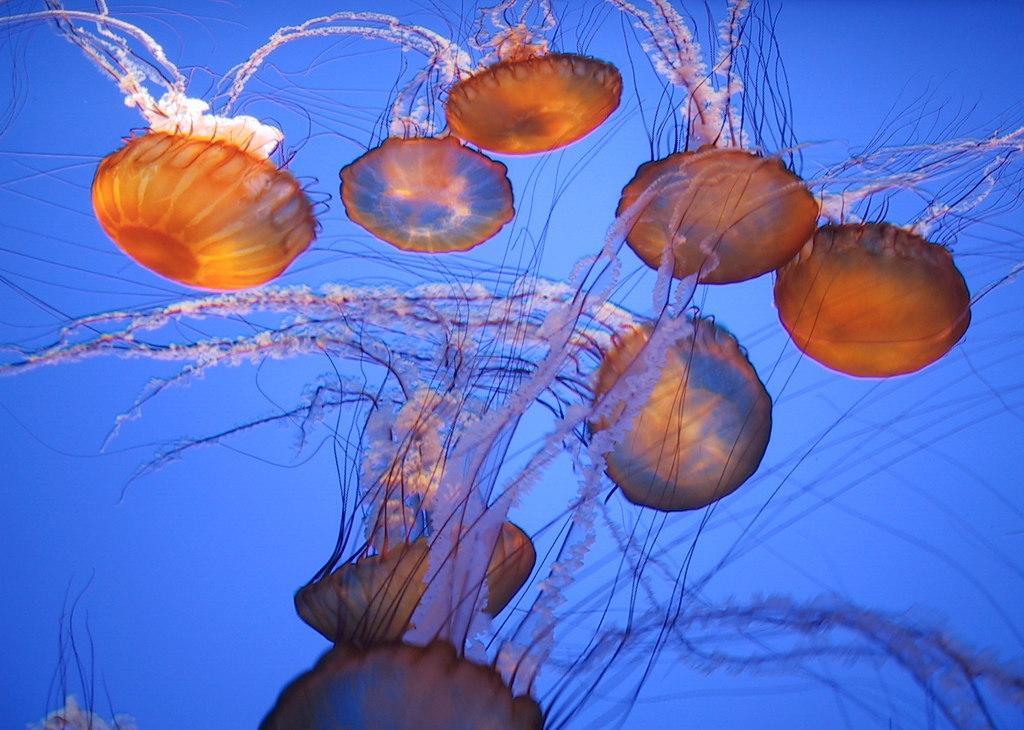In one or two sentences, can you explain what this image depicts? In this image we can see jellyfishes in the water. 